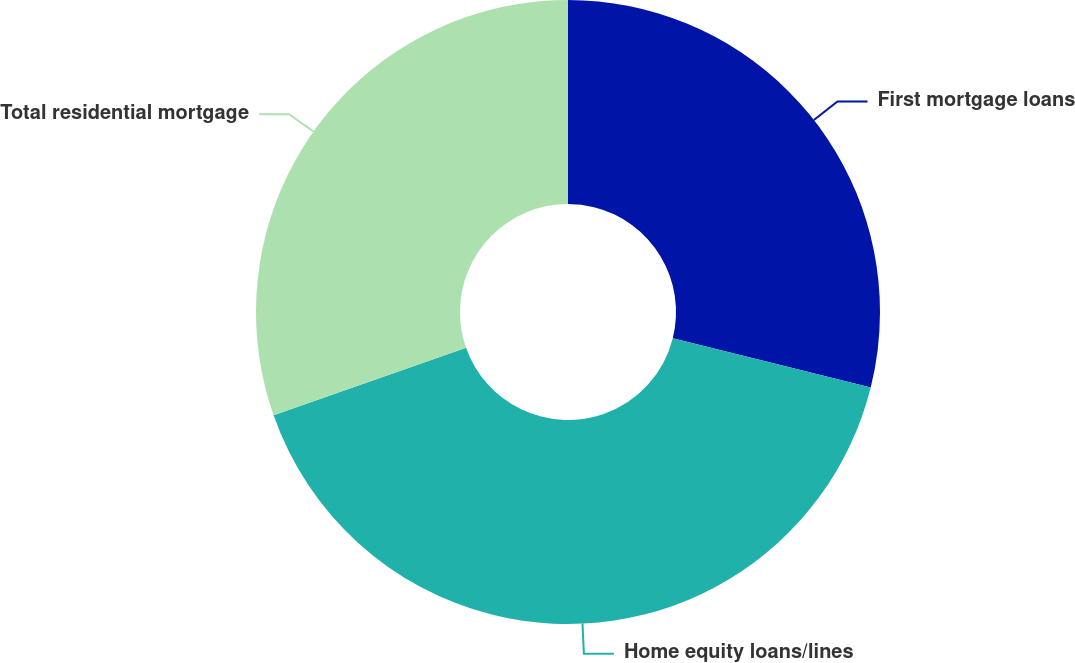Convert chart to OTSL. <chart><loc_0><loc_0><loc_500><loc_500><pie_chart><fcel>First mortgage loans<fcel>Home equity loans/lines<fcel>Total residential mortgage<nl><fcel>28.89%<fcel>40.74%<fcel>30.37%<nl></chart> 